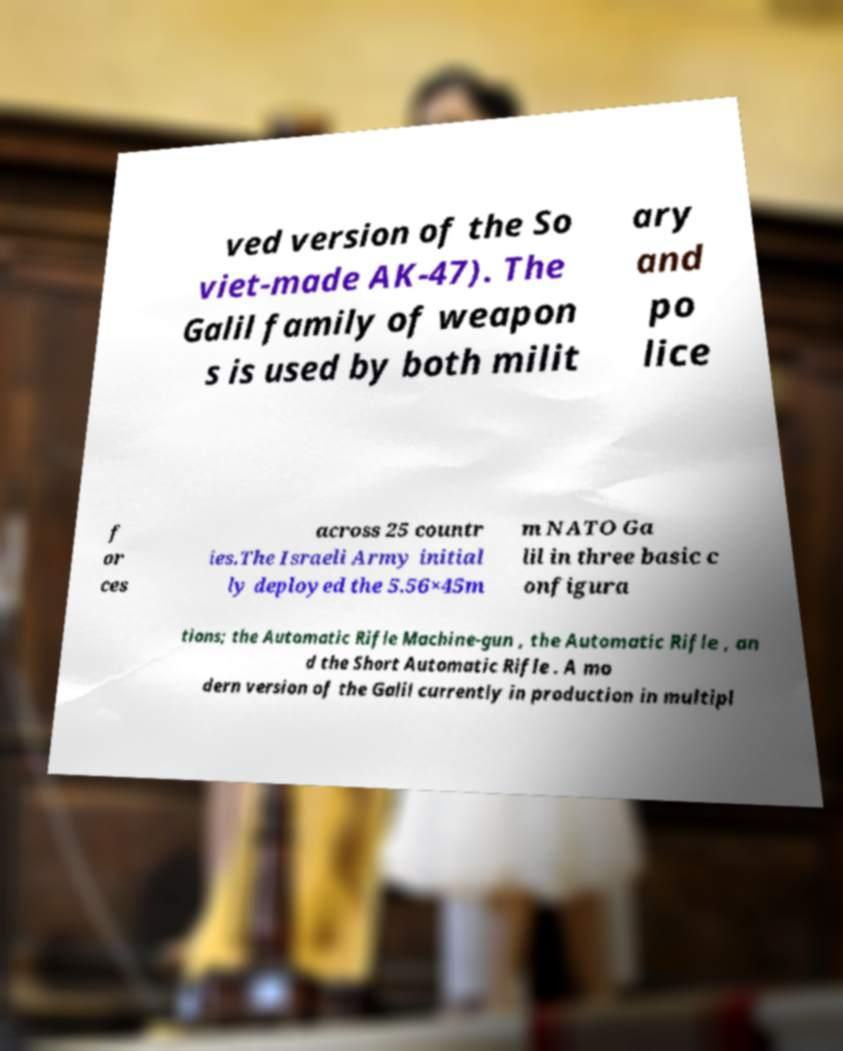Could you assist in decoding the text presented in this image and type it out clearly? ved version of the So viet-made AK-47). The Galil family of weapon s is used by both milit ary and po lice f or ces across 25 countr ies.The Israeli Army initial ly deployed the 5.56×45m m NATO Ga lil in three basic c onfigura tions; the Automatic Rifle Machine-gun , the Automatic Rifle , an d the Short Automatic Rifle . A mo dern version of the Galil currently in production in multipl 